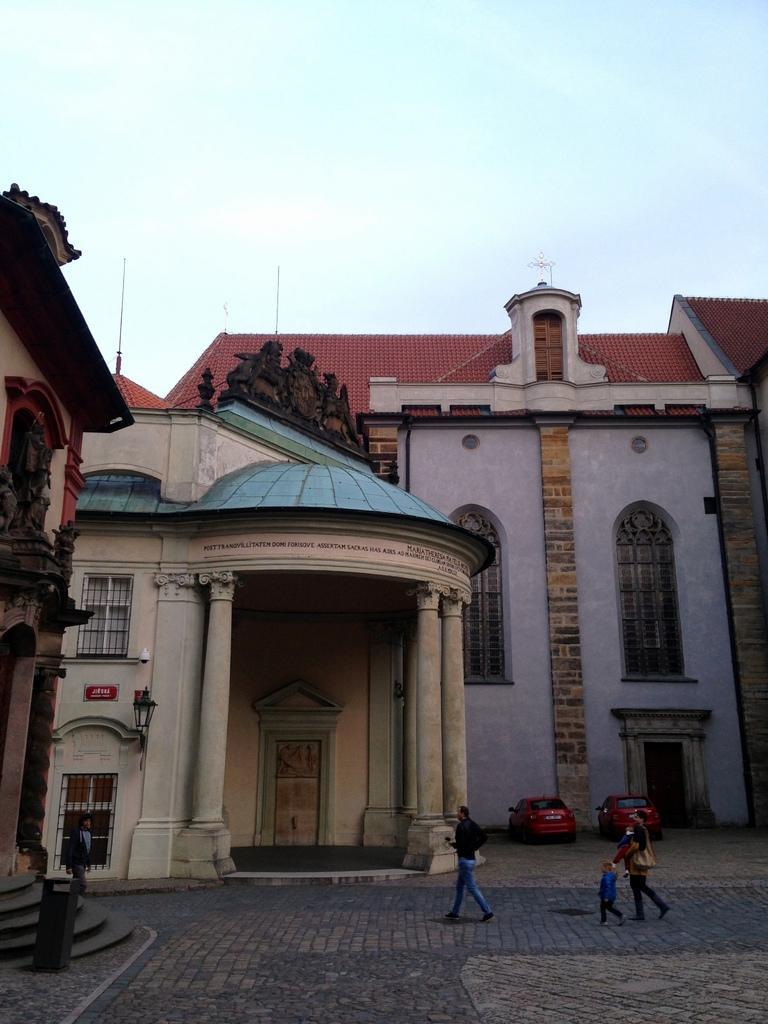Could you give a brief overview of what you see in this image? In this image there is a building, in front of the building there is a dustbin, few persons walking, there are two vehicles parking on the floor, in front of the building, at the top of the building there are some sculptures, at the top there is the sky, there is a lamp attached to the wall of the building in the middle. 